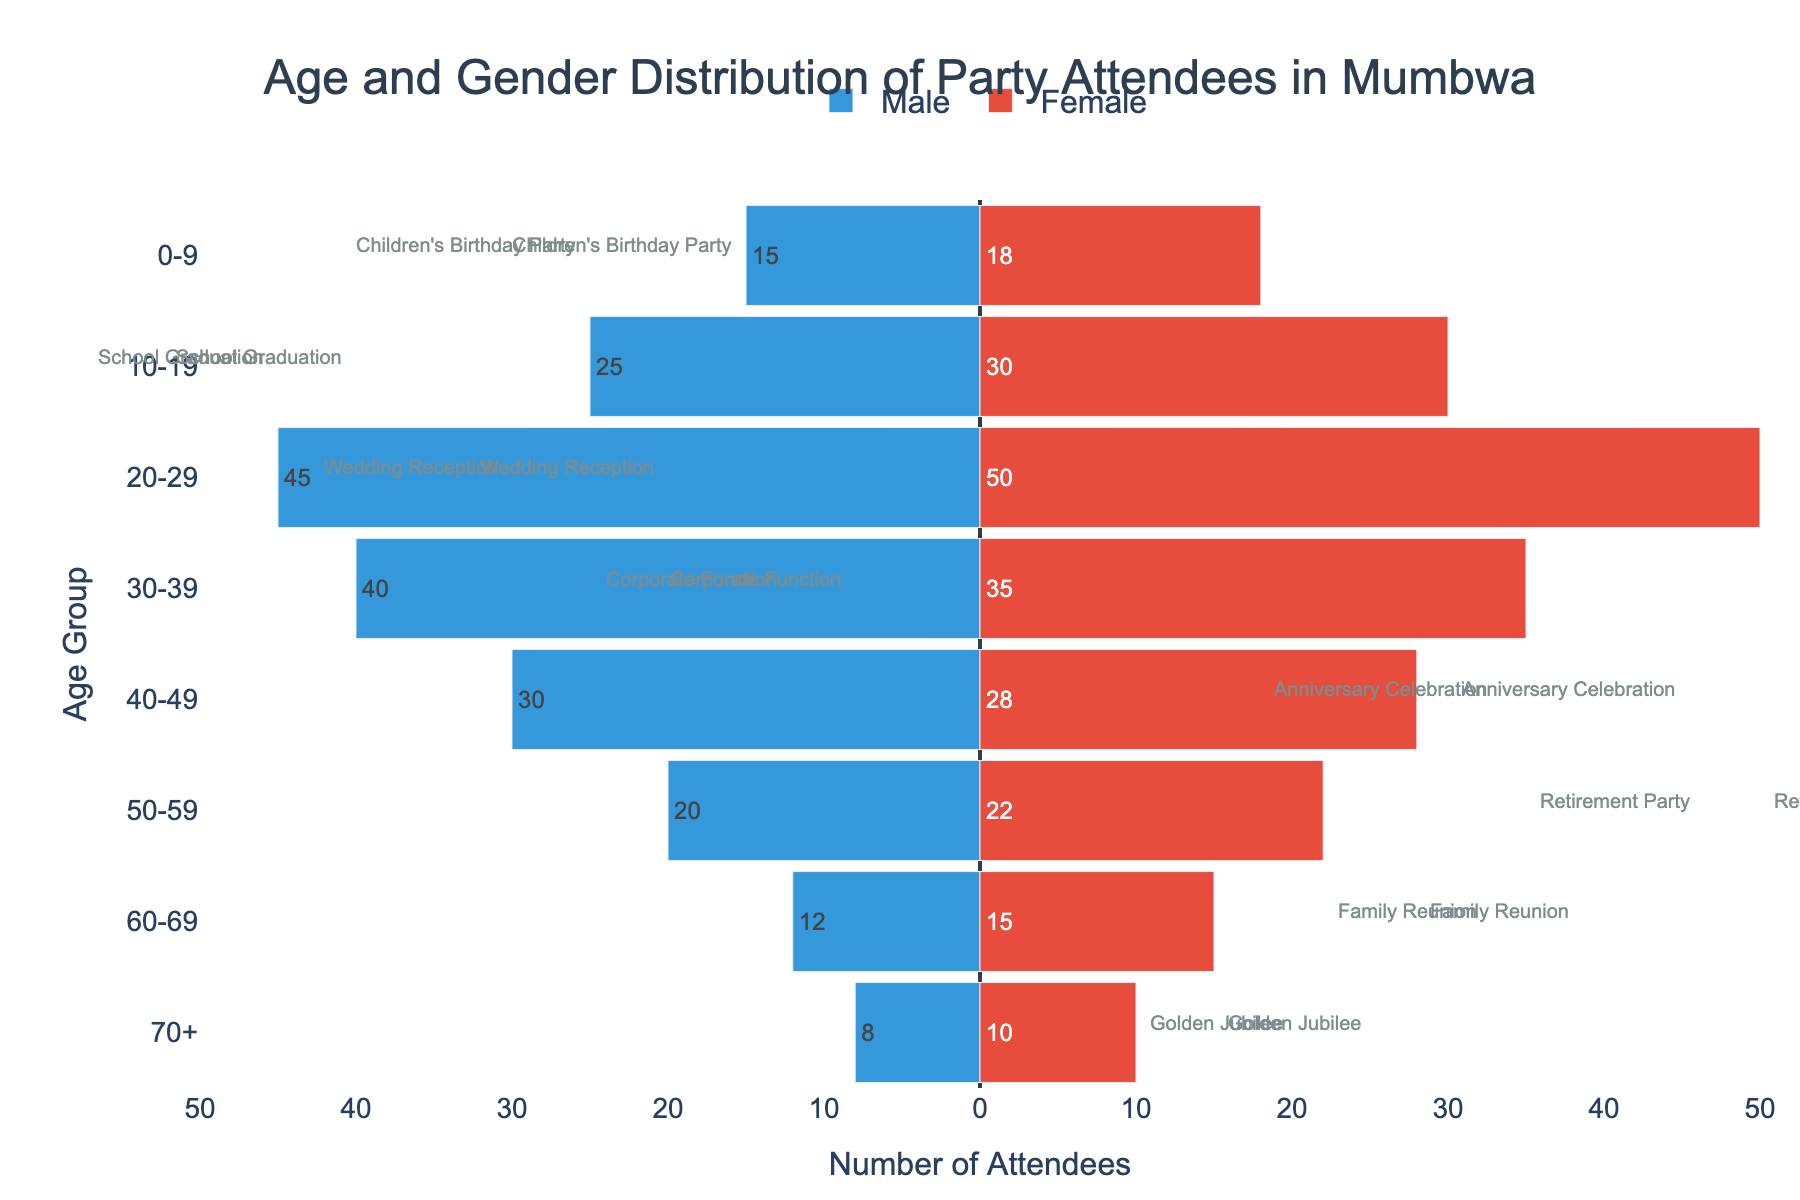How many age groups are represented in the plot? The age groups displayed on the vertical axis are "0-9", "10-19", "20-29", "30-39", "40-49", "50-59", "60-69", and "70+". Counting these, there are 8 age groups in total.
Answer: 8 Which event has the highest number of total attendees? For each event type, sum the number of male and female attendees: 
- Children's Birthday Party: 15 + 18 = 33
- School Graduation: 25 + 30 = 55
- Wedding Reception: 45 + 50 = 95
- Corporate Function: 40 + 35 = 75
- Anniversary Celebration: 30 + 28 = 58
- Retirement Party: 20 + 22 = 42
- Family Reunion: 12 + 15 = 27
- Golden Jubilee: 8 + 10 = 18
The Wedding Reception has the highest total number of attendees at 95.
Answer: Wedding Reception In which age group do males outnumber females the most? For each age group, find the difference between the numbers of male and female attendees:
- 0-9: 15 - 18 = -3
- 10-19: 25 - 30 = -5
- 20-29: 45 - 50 = -5
- 30-39: 40 - 35 = 5
- 40-49: 30 - 28 = 2
- 50-59: 20 - 22 = -2
- 60-69: 12 - 15 = -3
- 70+: 8 - 10 = -2
Males outnumber females the most in the 30-39 age group by 5 attendees.
Answer: 30-39 What is the total number of male attendees aged 30-39? According to the plot, the number of male attendees in the 30-39 age group is represented by a blue bar with a value of 40.
Answer: 40 